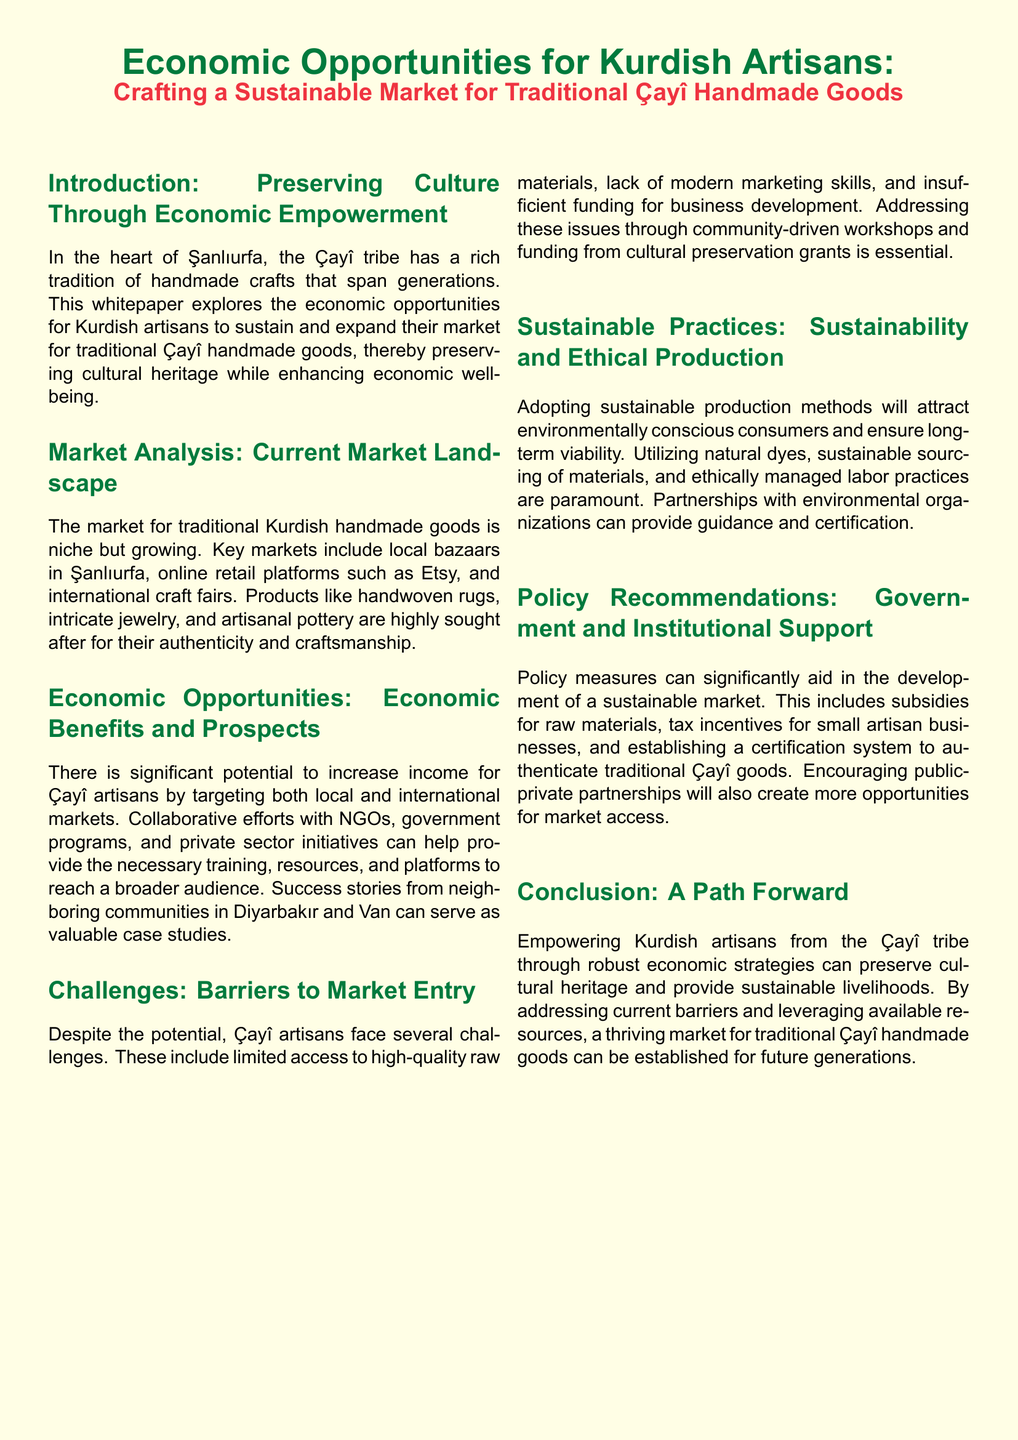What is the title of the whitepaper? The title is directly mentioned in the document's header section.
Answer: Economic Opportunities for Kurdish Artisans: Crafting a Sustainable Market for Traditional Çayî Handmade Goods Which tribe's artisans are the focus of this whitepaper? The document specifies the artisans from the Çayî tribe in its introduction.
Answer: Çayî tribe What is a key market for traditional Kurdish handmade goods? The document lists local bazaars in Şanlıurfa as one of the key markets.
Answer: Local bazaars in Şanlıurfa What is one significant challenge faced by Çayî artisans? The document outlines barriers such as limited access to high-quality raw materials.
Answer: Limited access to high-quality raw materials What type of marketing platforms are mentioned in the document? The document mentions online retail platforms as a type of marketing platform.
Answer: Online retail platforms What is one policy recommendation stated in the document? The document highlights the creation of a certification system to authenticate traditional Çayî goods as a recommendation.
Answer: Certification system to authenticate traditional Çayî goods What production method is encouraged for sustainability? Sustainable sourcing of materials is emphasized for ethical production practices.
Answer: Sustainable sourcing of materials Which neighboring communities serve as case studies? The document specifically mentions communities in Diyarbakır and Van as success stories.
Answer: Diyarbakır and Van 